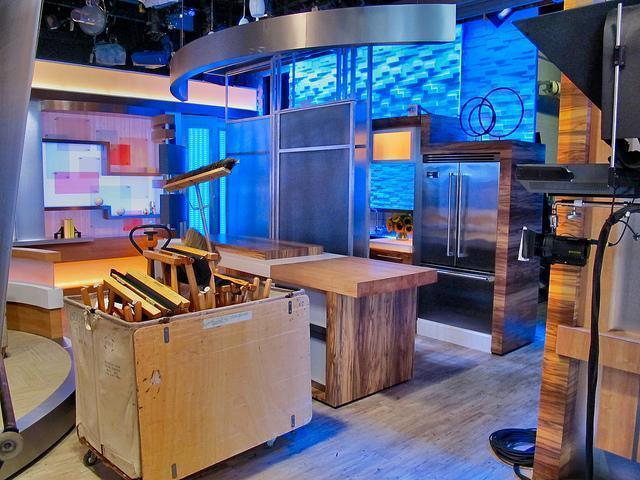How many bears are in the chair?
Give a very brief answer. 0. 